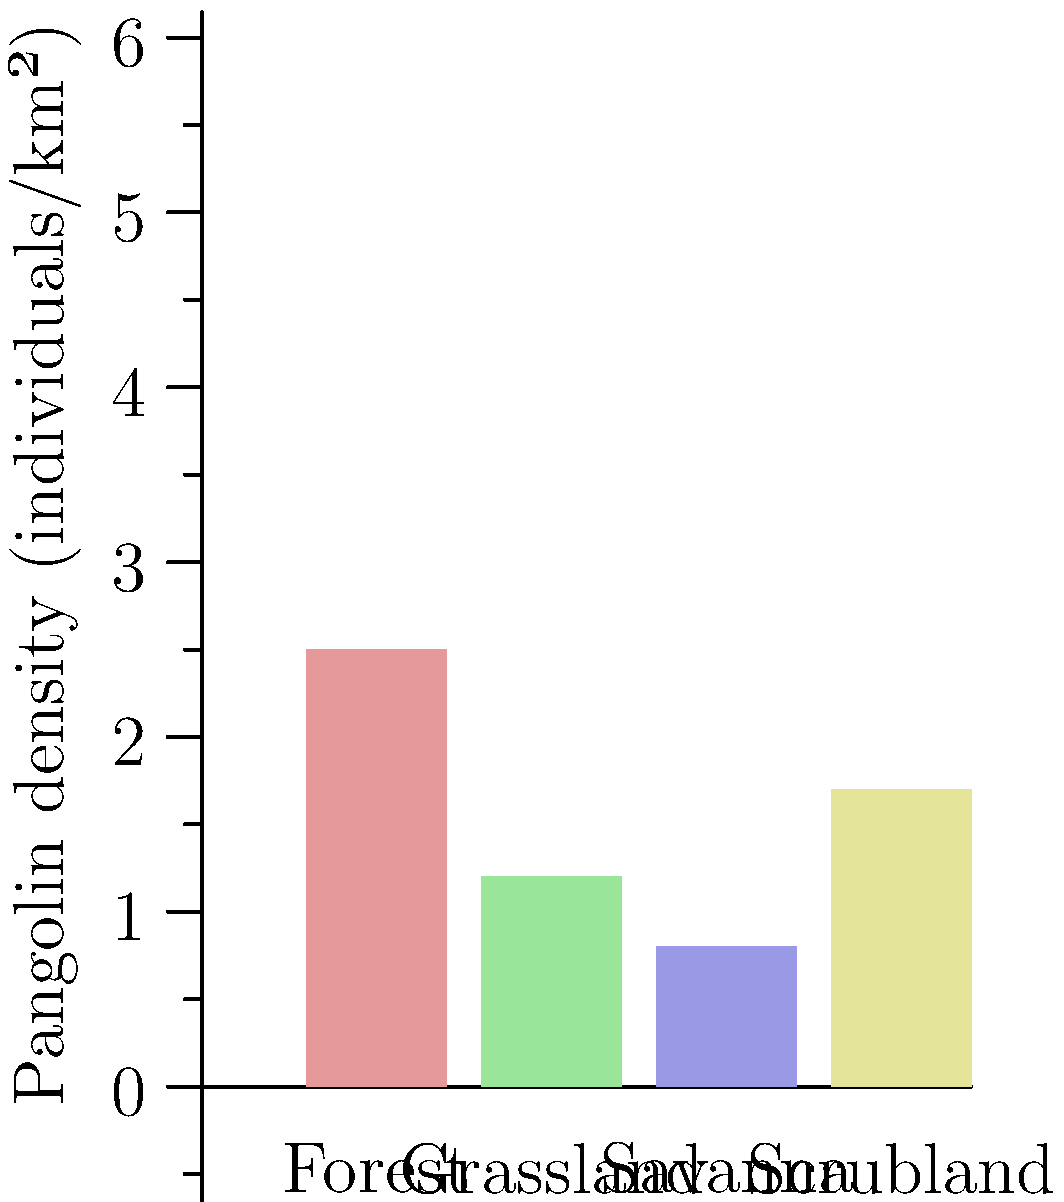Based on the color-coded map of pangolin population density across different habitats, which habitat type shows the highest density, and what factors might contribute to this distribution pattern? To answer this question, we need to analyze the graph and consider ecological factors:

1. Interpret the graph:
   - The x-axis shows four habitat types: Forest, Grassland, Savanna, and Scrubland.
   - The y-axis represents pangolin density in individuals per square kilometer.
   - Each bar is color-coded to indicate the density range.

2. Identify the highest density:
   - Forest habitat has the tallest bar, reaching about 2.5 individuals/km².
   - This is significantly higher than other habitats.

3. Factors contributing to higher density in forests:
   a) Food availability: Forests likely provide abundant insects (e.g., ants, termites) that pangolins feed on.
   b) Protection: Dense vegetation offers cover from predators and poachers.
   c) Microclimate: Forests maintain stable temperatures and humidity, suitable for pangolins.
   d) Nesting sites: Trees and fallen logs offer ideal burrowing and nesting locations.

4. Compare with other habitats:
   - Scrubland shows the second-highest density (about 1.7 individuals/km²).
   - Grassland and Savanna have lower densities, possibly due to less cover and fewer nesting options.

5. Conservation implications:
   - Forest conservation is crucial for pangolin protection.
   - Habitat connectivity between forests and other areas may be important for population sustainability.

The high density in forests underscores the importance of this habitat type for pangolin conservation efforts.
Answer: Forest habitat; abundant food, protection, suitable microclimate, and nesting sites. 